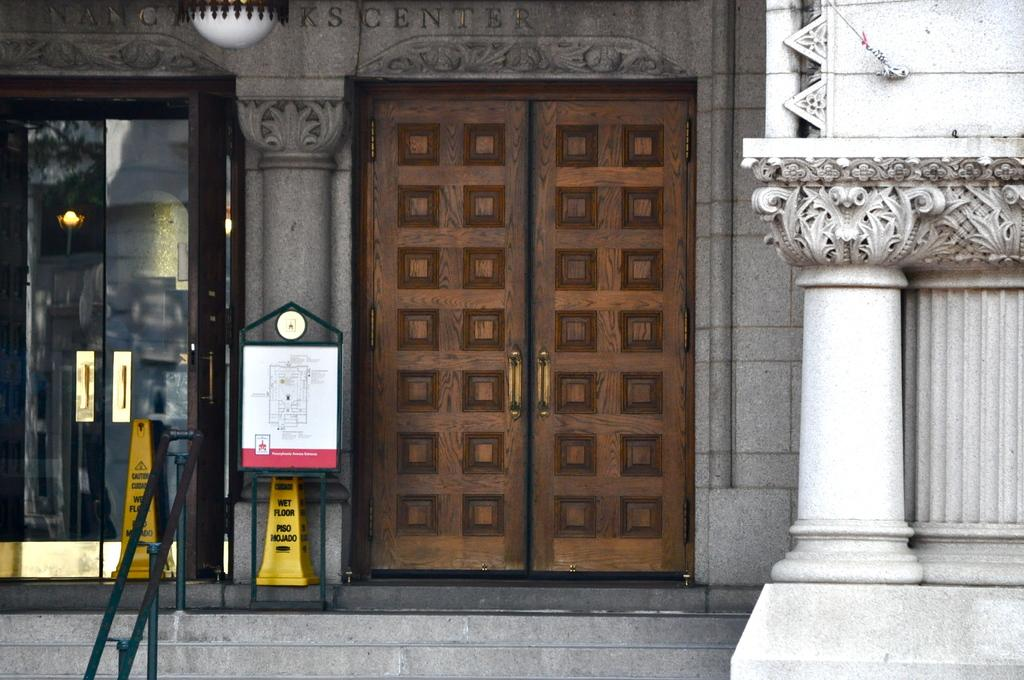What architectural feature can be seen in the image? There are steps in the image. What can be found at the entrance of the building in the image? There are doors in the image. What is the source of light in the image? There is light in the image. What structural elements support the building in the image? There are pillars in the image. What part of the building is visible in the image? There is a building wall in the image. Can you determine the time of day when the image was taken? The image was likely taken during the day, as there is sufficient light. What type of screw is being used to hold the governor's speech in the image? There is no governor or speech present in the image, so it is not possible to determine the type of screw being used. 